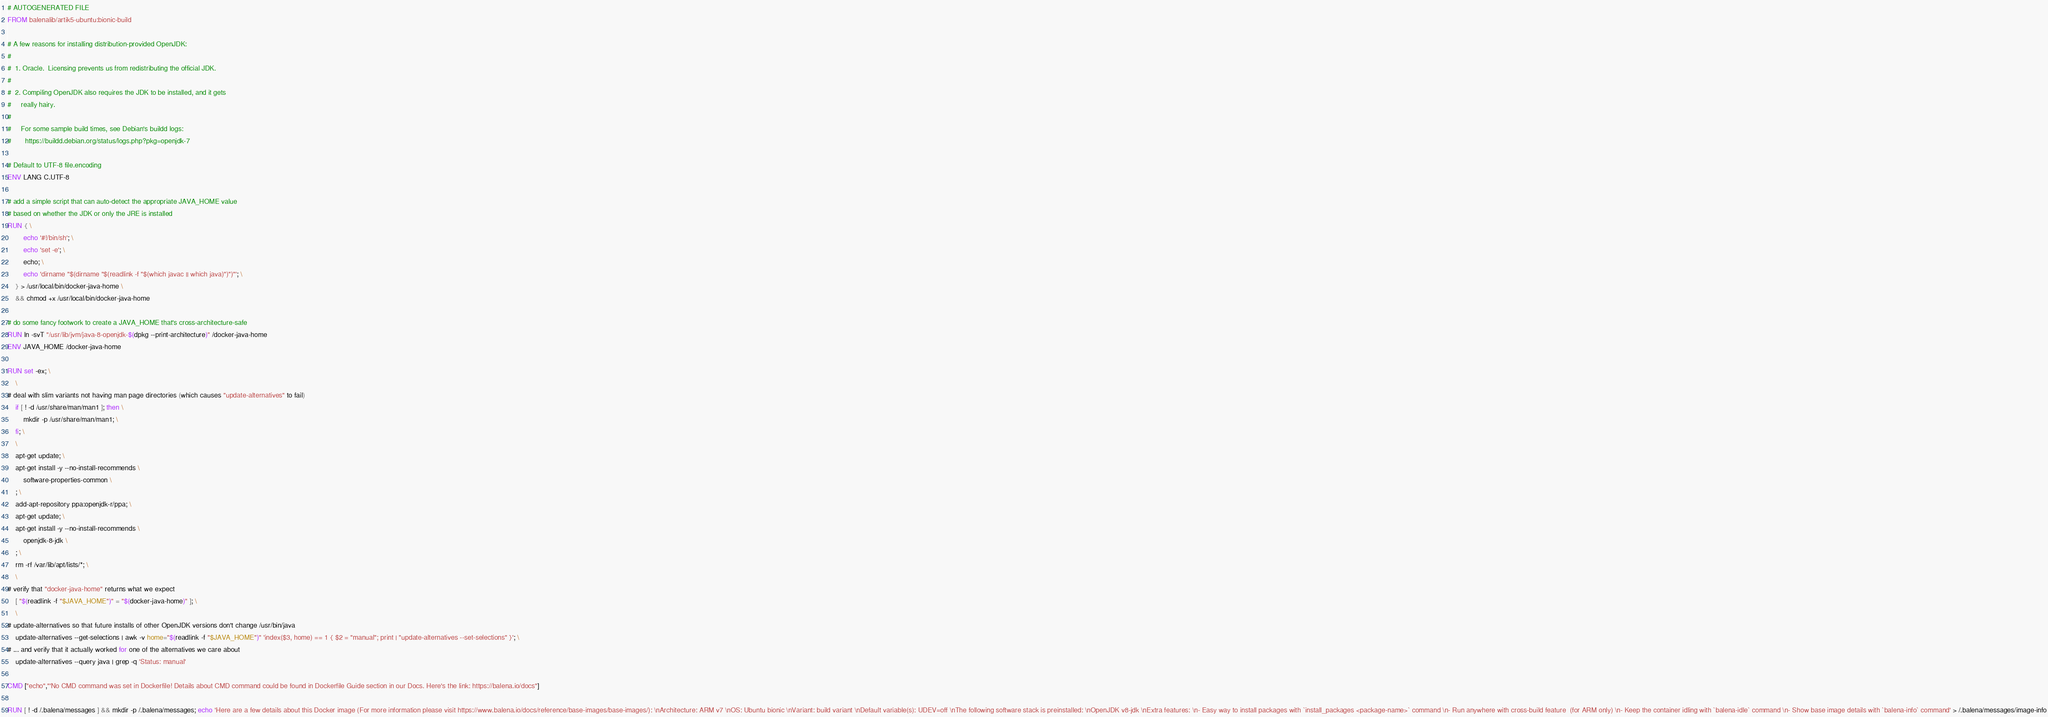Convert code to text. <code><loc_0><loc_0><loc_500><loc_500><_Dockerfile_># AUTOGENERATED FILE
FROM balenalib/artik5-ubuntu:bionic-build

# A few reasons for installing distribution-provided OpenJDK:
#
#  1. Oracle.  Licensing prevents us from redistributing the official JDK.
#
#  2. Compiling OpenJDK also requires the JDK to be installed, and it gets
#     really hairy.
#
#     For some sample build times, see Debian's buildd logs:
#       https://buildd.debian.org/status/logs.php?pkg=openjdk-7

# Default to UTF-8 file.encoding
ENV LANG C.UTF-8

# add a simple script that can auto-detect the appropriate JAVA_HOME value
# based on whether the JDK or only the JRE is installed
RUN { \
		echo '#!/bin/sh'; \
		echo 'set -e'; \
		echo; \
		echo 'dirname "$(dirname "$(readlink -f "$(which javac || which java)")")"'; \
	} > /usr/local/bin/docker-java-home \
	&& chmod +x /usr/local/bin/docker-java-home

# do some fancy footwork to create a JAVA_HOME that's cross-architecture-safe
RUN ln -svT "/usr/lib/jvm/java-8-openjdk-$(dpkg --print-architecture)" /docker-java-home
ENV JAVA_HOME /docker-java-home

RUN set -ex; \
	\
# deal with slim variants not having man page directories (which causes "update-alternatives" to fail)
	if [ ! -d /usr/share/man/man1 ]; then \
		mkdir -p /usr/share/man/man1; \
	fi; \
	\
	apt-get update; \
	apt-get install -y --no-install-recommends \
		software-properties-common \
	; \
	add-apt-repository ppa:openjdk-r/ppa; \
	apt-get update; \
	apt-get install -y --no-install-recommends \
		openjdk-8-jdk \
	; \
	rm -rf /var/lib/apt/lists/*; \
	\
# verify that "docker-java-home" returns what we expect
	[ "$(readlink -f "$JAVA_HOME")" = "$(docker-java-home)" ]; \
	\
# update-alternatives so that future installs of other OpenJDK versions don't change /usr/bin/java
	update-alternatives --get-selections | awk -v home="$(readlink -f "$JAVA_HOME")" 'index($3, home) == 1 { $2 = "manual"; print | "update-alternatives --set-selections" }'; \
# ... and verify that it actually worked for one of the alternatives we care about
	update-alternatives --query java | grep -q 'Status: manual'

CMD ["echo","'No CMD command was set in Dockerfile! Details about CMD command could be found in Dockerfile Guide section in our Docs. Here's the link: https://balena.io/docs"]

RUN [ ! -d /.balena/messages ] && mkdir -p /.balena/messages; echo 'Here are a few details about this Docker image (For more information please visit https://www.balena.io/docs/reference/base-images/base-images/): \nArchitecture: ARM v7 \nOS: Ubuntu bionic \nVariant: build variant \nDefault variable(s): UDEV=off \nThe following software stack is preinstalled: \nOpenJDK v8-jdk \nExtra features: \n- Easy way to install packages with `install_packages <package-name>` command \n- Run anywhere with cross-build feature  (for ARM only) \n- Keep the container idling with `balena-idle` command \n- Show base image details with `balena-info` command' > /.balena/messages/image-info</code> 